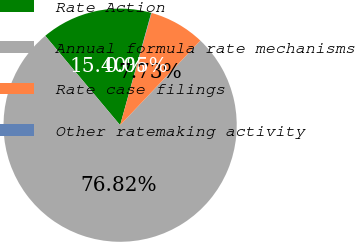<chart> <loc_0><loc_0><loc_500><loc_500><pie_chart><fcel>Rate Action<fcel>Annual formula rate mechanisms<fcel>Rate case filings<fcel>Other ratemaking activity<nl><fcel>15.4%<fcel>76.81%<fcel>7.73%<fcel>0.05%<nl></chart> 